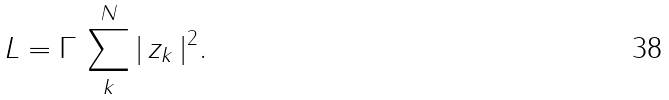Convert formula to latex. <formula><loc_0><loc_0><loc_500><loc_500>L = \Gamma \, \sum _ { k } ^ { N } | \, z _ { k } \, | ^ { 2 } .</formula> 